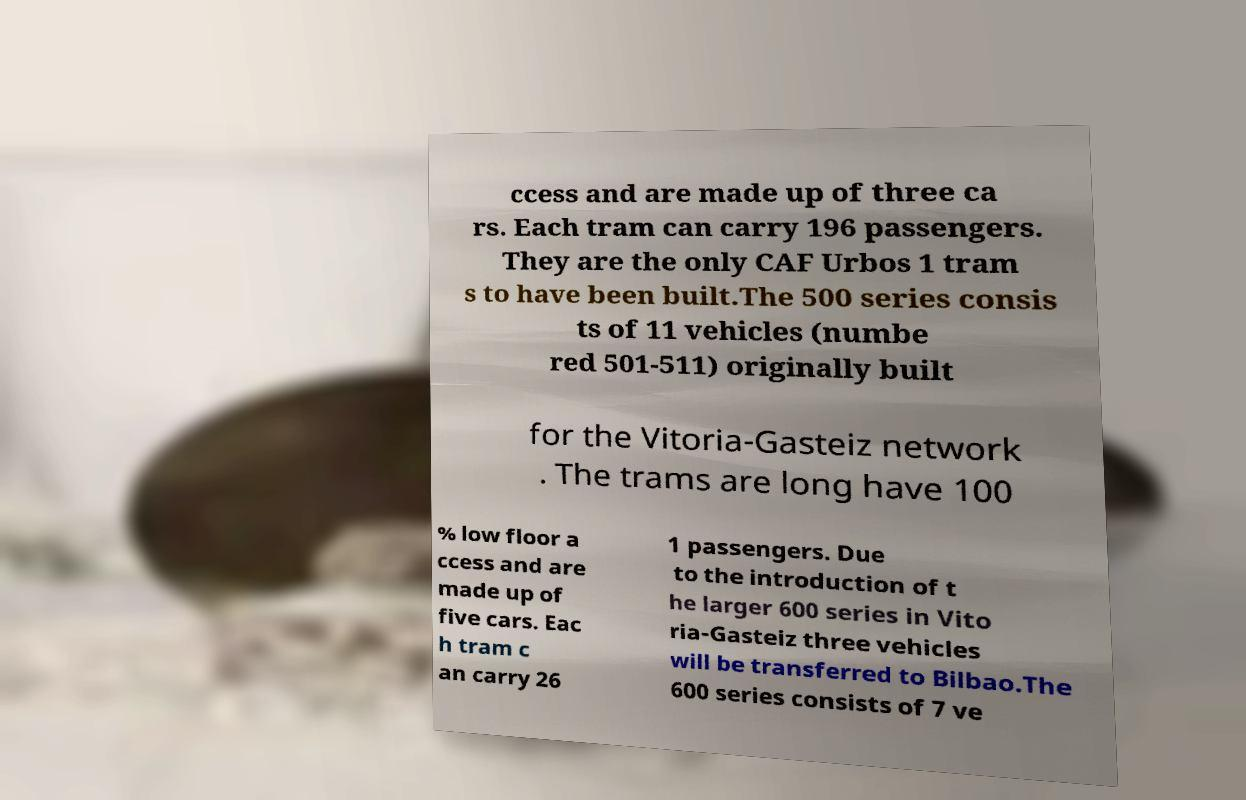Please read and relay the text visible in this image. What does it say? ccess and are made up of three ca rs. Each tram can carry 196 passengers. They are the only CAF Urbos 1 tram s to have been built.The 500 series consis ts of 11 vehicles (numbe red 501-511) originally built for the Vitoria-Gasteiz network . The trams are long have 100 % low floor a ccess and are made up of five cars. Eac h tram c an carry 26 1 passengers. Due to the introduction of t he larger 600 series in Vito ria-Gasteiz three vehicles will be transferred to Bilbao.The 600 series consists of 7 ve 